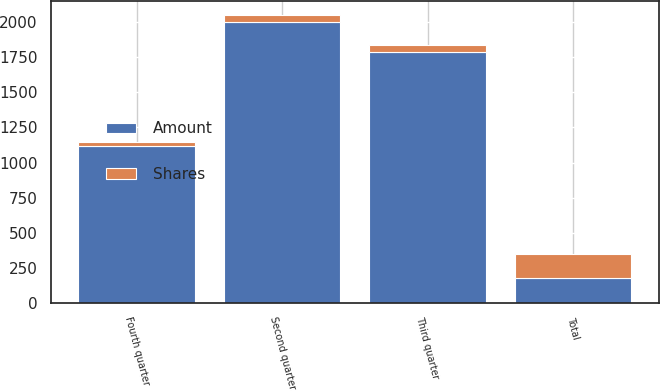<chart> <loc_0><loc_0><loc_500><loc_500><stacked_bar_chart><ecel><fcel>Second quarter<fcel>Third quarter<fcel>Fourth quarter<fcel>Total<nl><fcel>Shares<fcel>53<fcel>47<fcel>28<fcel>175<nl><fcel>Amount<fcel>2000<fcel>1791<fcel>1118<fcel>175<nl></chart> 